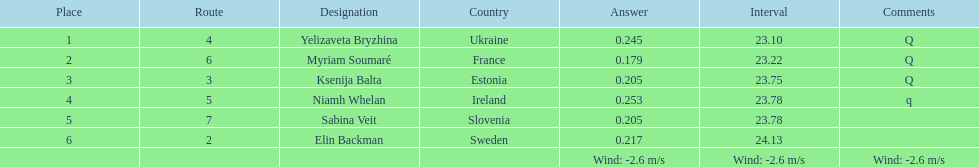What number of last names start with "b"? 3. Give me the full table as a dictionary. {'header': ['Place', 'Route', 'Designation', 'Country', 'Answer', 'Interval', 'Comments'], 'rows': [['1', '4', 'Yelizaveta Bryzhina', 'Ukraine', '0.245', '23.10', 'Q'], ['2', '6', 'Myriam Soumaré', 'France', '0.179', '23.22', 'Q'], ['3', '3', 'Ksenija Balta', 'Estonia', '0.205', '23.75', 'Q'], ['4', '5', 'Niamh Whelan', 'Ireland', '0.253', '23.78', 'q'], ['5', '7', 'Sabina Veit', 'Slovenia', '0.205', '23.78', ''], ['6', '2', 'Elin Backman', 'Sweden', '0.217', '24.13', ''], ['', '', '', '', 'Wind: -2.6\xa0m/s', 'Wind: -2.6\xa0m/s', 'Wind: -2.6\xa0m/s']]} 